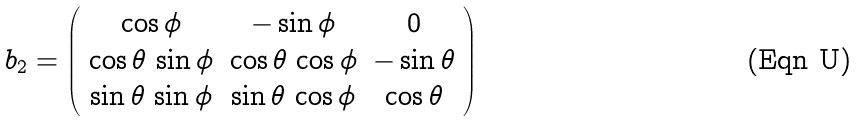Convert formula to latex. <formula><loc_0><loc_0><loc_500><loc_500>b _ { 2 } = \left ( \begin{array} { c c c } \cos \phi & - \sin \phi & 0 \\ \cos \theta \, \sin \phi & \cos \theta \, \cos \phi & - \sin \theta \\ \sin \theta \, \sin \phi & \sin \theta \, \cos \phi & \cos \theta \end{array} \right )</formula> 